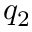Convert formula to latex. <formula><loc_0><loc_0><loc_500><loc_500>q _ { 2 }</formula> 